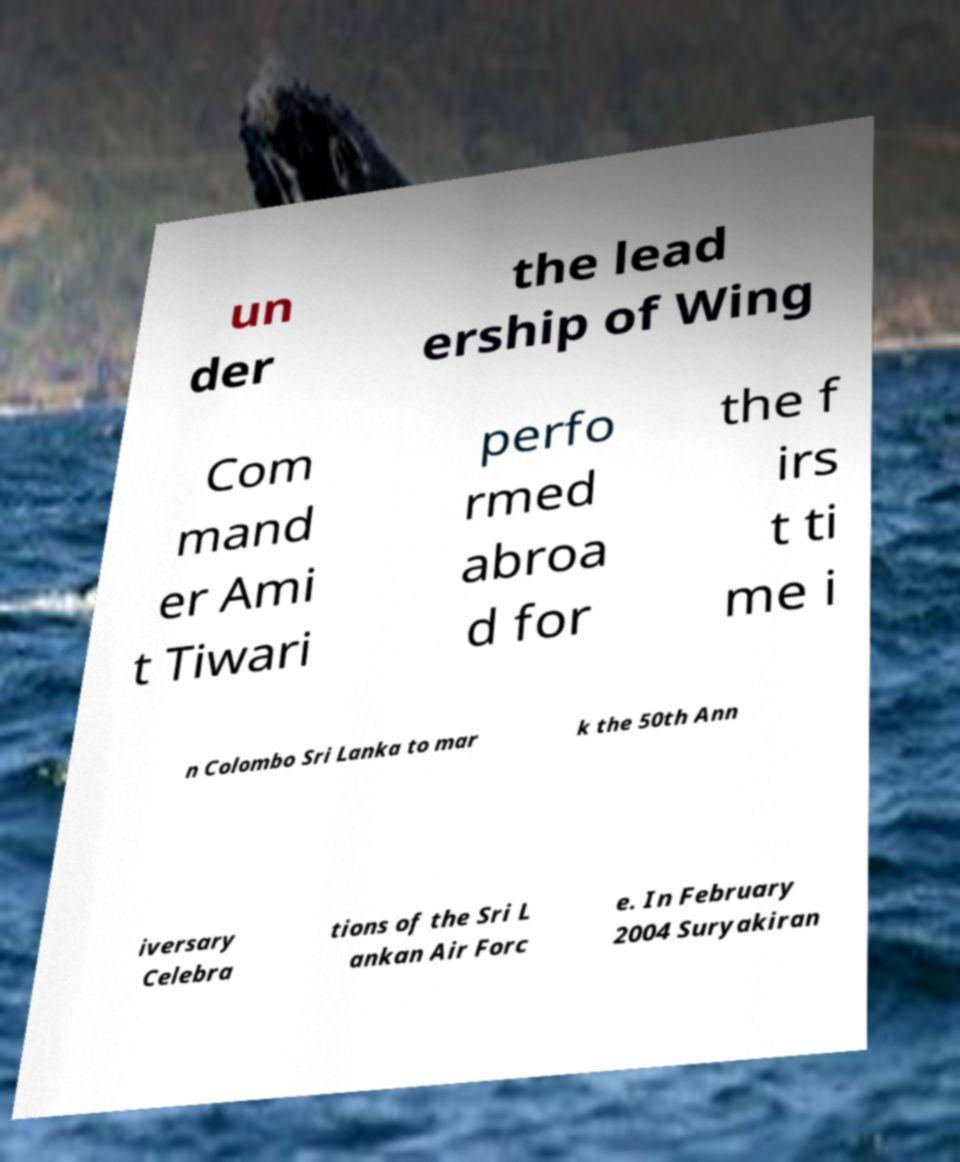What messages or text are displayed in this image? I need them in a readable, typed format. un der the lead ership of Wing Com mand er Ami t Tiwari perfo rmed abroa d for the f irs t ti me i n Colombo Sri Lanka to mar k the 50th Ann iversary Celebra tions of the Sri L ankan Air Forc e. In February 2004 Suryakiran 